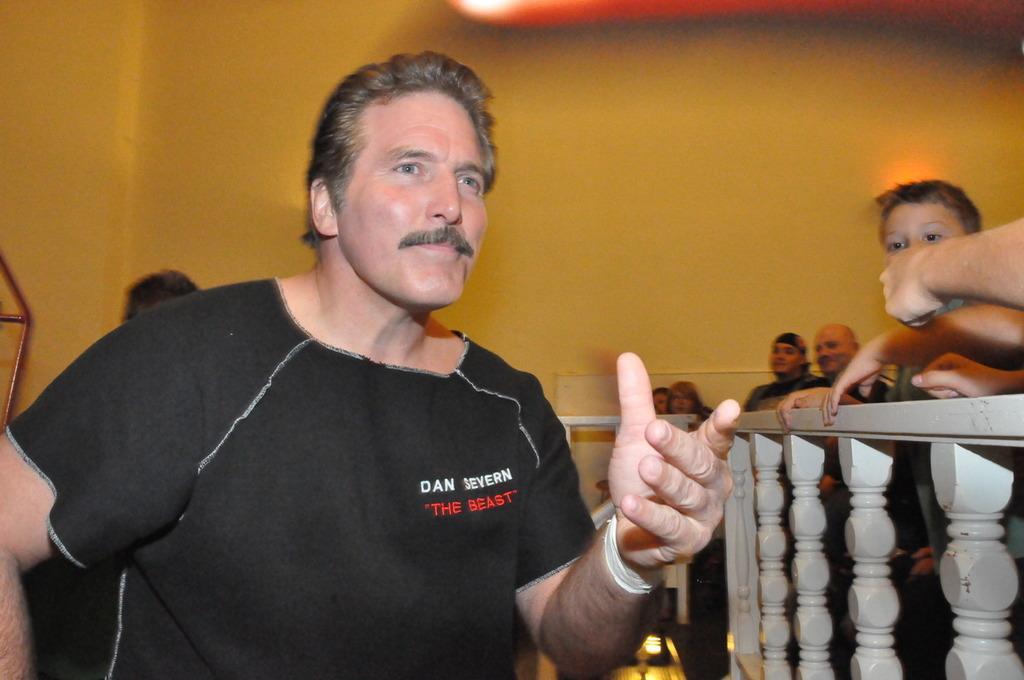Can you describe this image briefly? In the image I can see a person who is wearing the black tee shirt and standing beside the fencing and also I can see some other people to the other side of the fencing. 